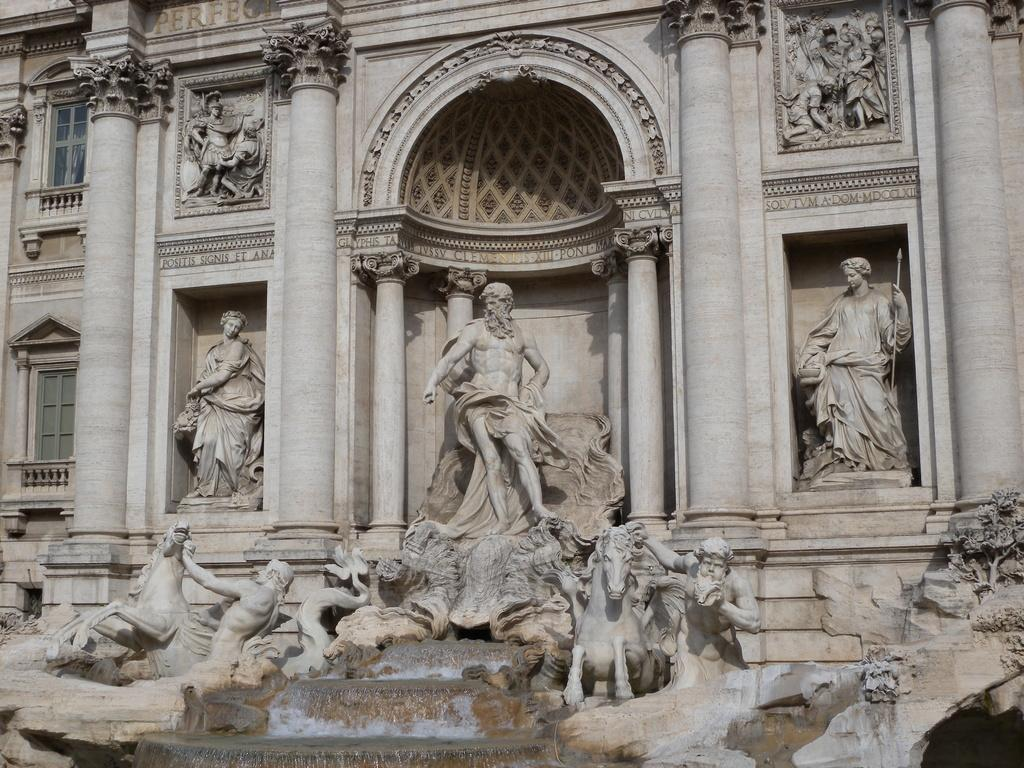What type of structure is visible in the image? There is a building in the image. What other artistic elements can be seen in the image? There are multiple sculptures in the image. What type of paper is the father holding in the image? There is no father or paper present in the image. 